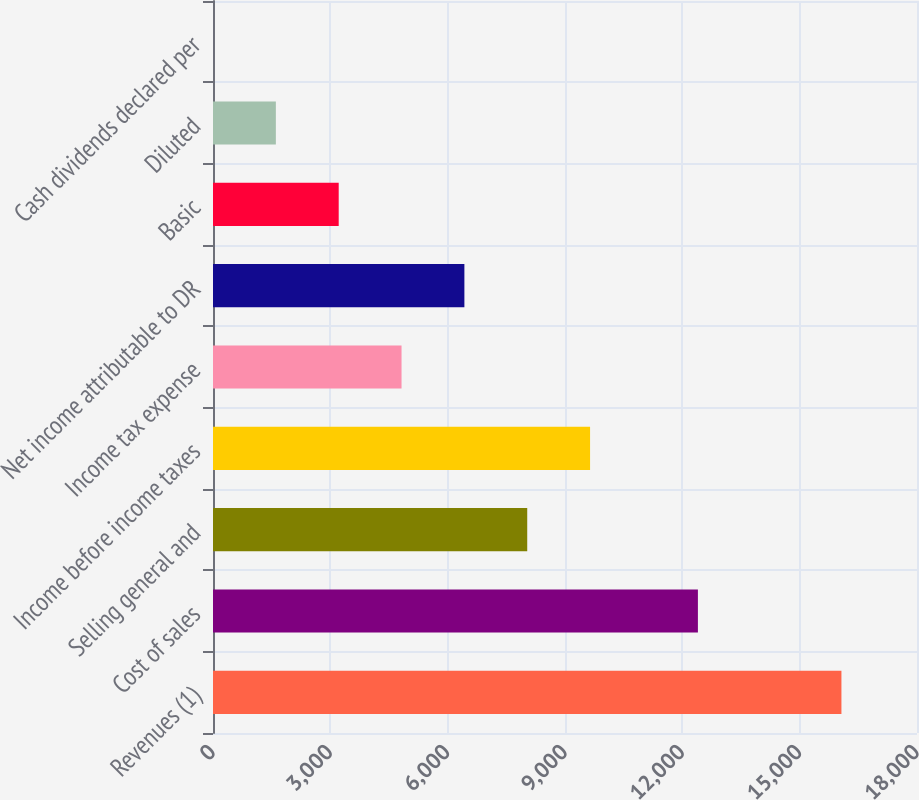Convert chart. <chart><loc_0><loc_0><loc_500><loc_500><bar_chart><fcel>Revenues (1)<fcel>Cost of sales<fcel>Selling general and<fcel>Income before income taxes<fcel>Income tax expense<fcel>Net income attributable to DR<fcel>Basic<fcel>Diluted<fcel>Cash dividends declared per<nl><fcel>16068<fcel>12398.1<fcel>8034.25<fcel>9641<fcel>4820.75<fcel>6427.5<fcel>3214<fcel>1607.25<fcel>0.5<nl></chart> 